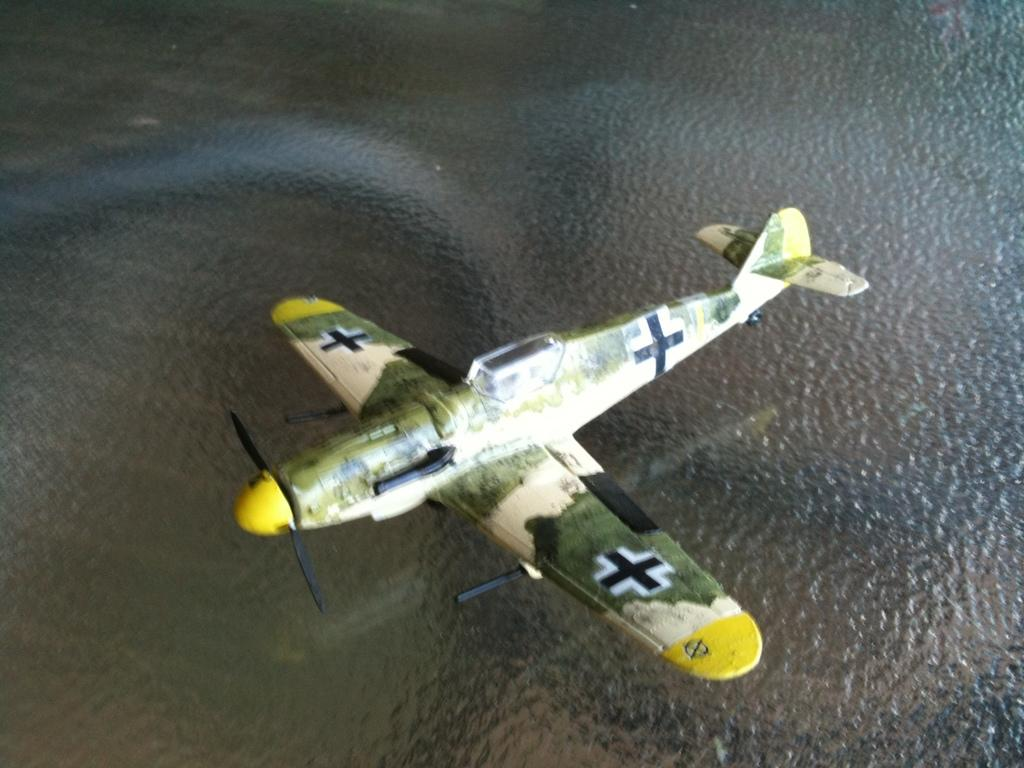What is the main subject of the image? The main subject of the image is an aircraft. Where is the aircraft located in the image? The aircraft is in the air. What can be seen at the bottom of the image? There is a water body at the bottom of the image. Can you see any flames coming from the aircraft in the image? No, there are no flames visible in the image. What type of seed is growing near the water body in the image? There is no seed present in the image; it only features an aircraft in the air and a water body below. 